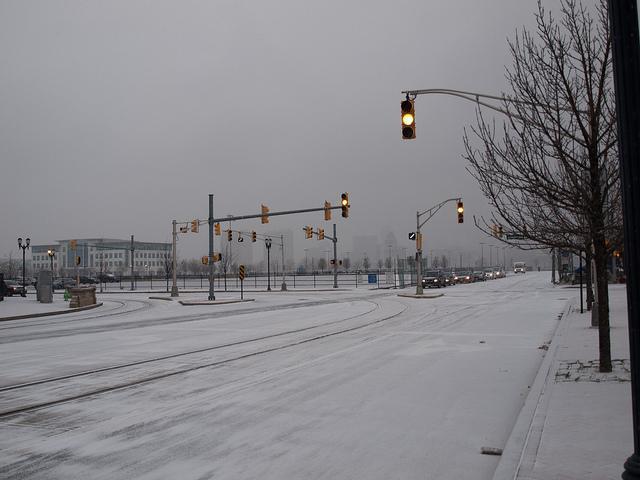Why has caused traffic to be so light on this roadway?
Indicate the correct response by choosing from the four available options to answer the question.
Options: Flooding, rain, tornados, snow. Snow. 